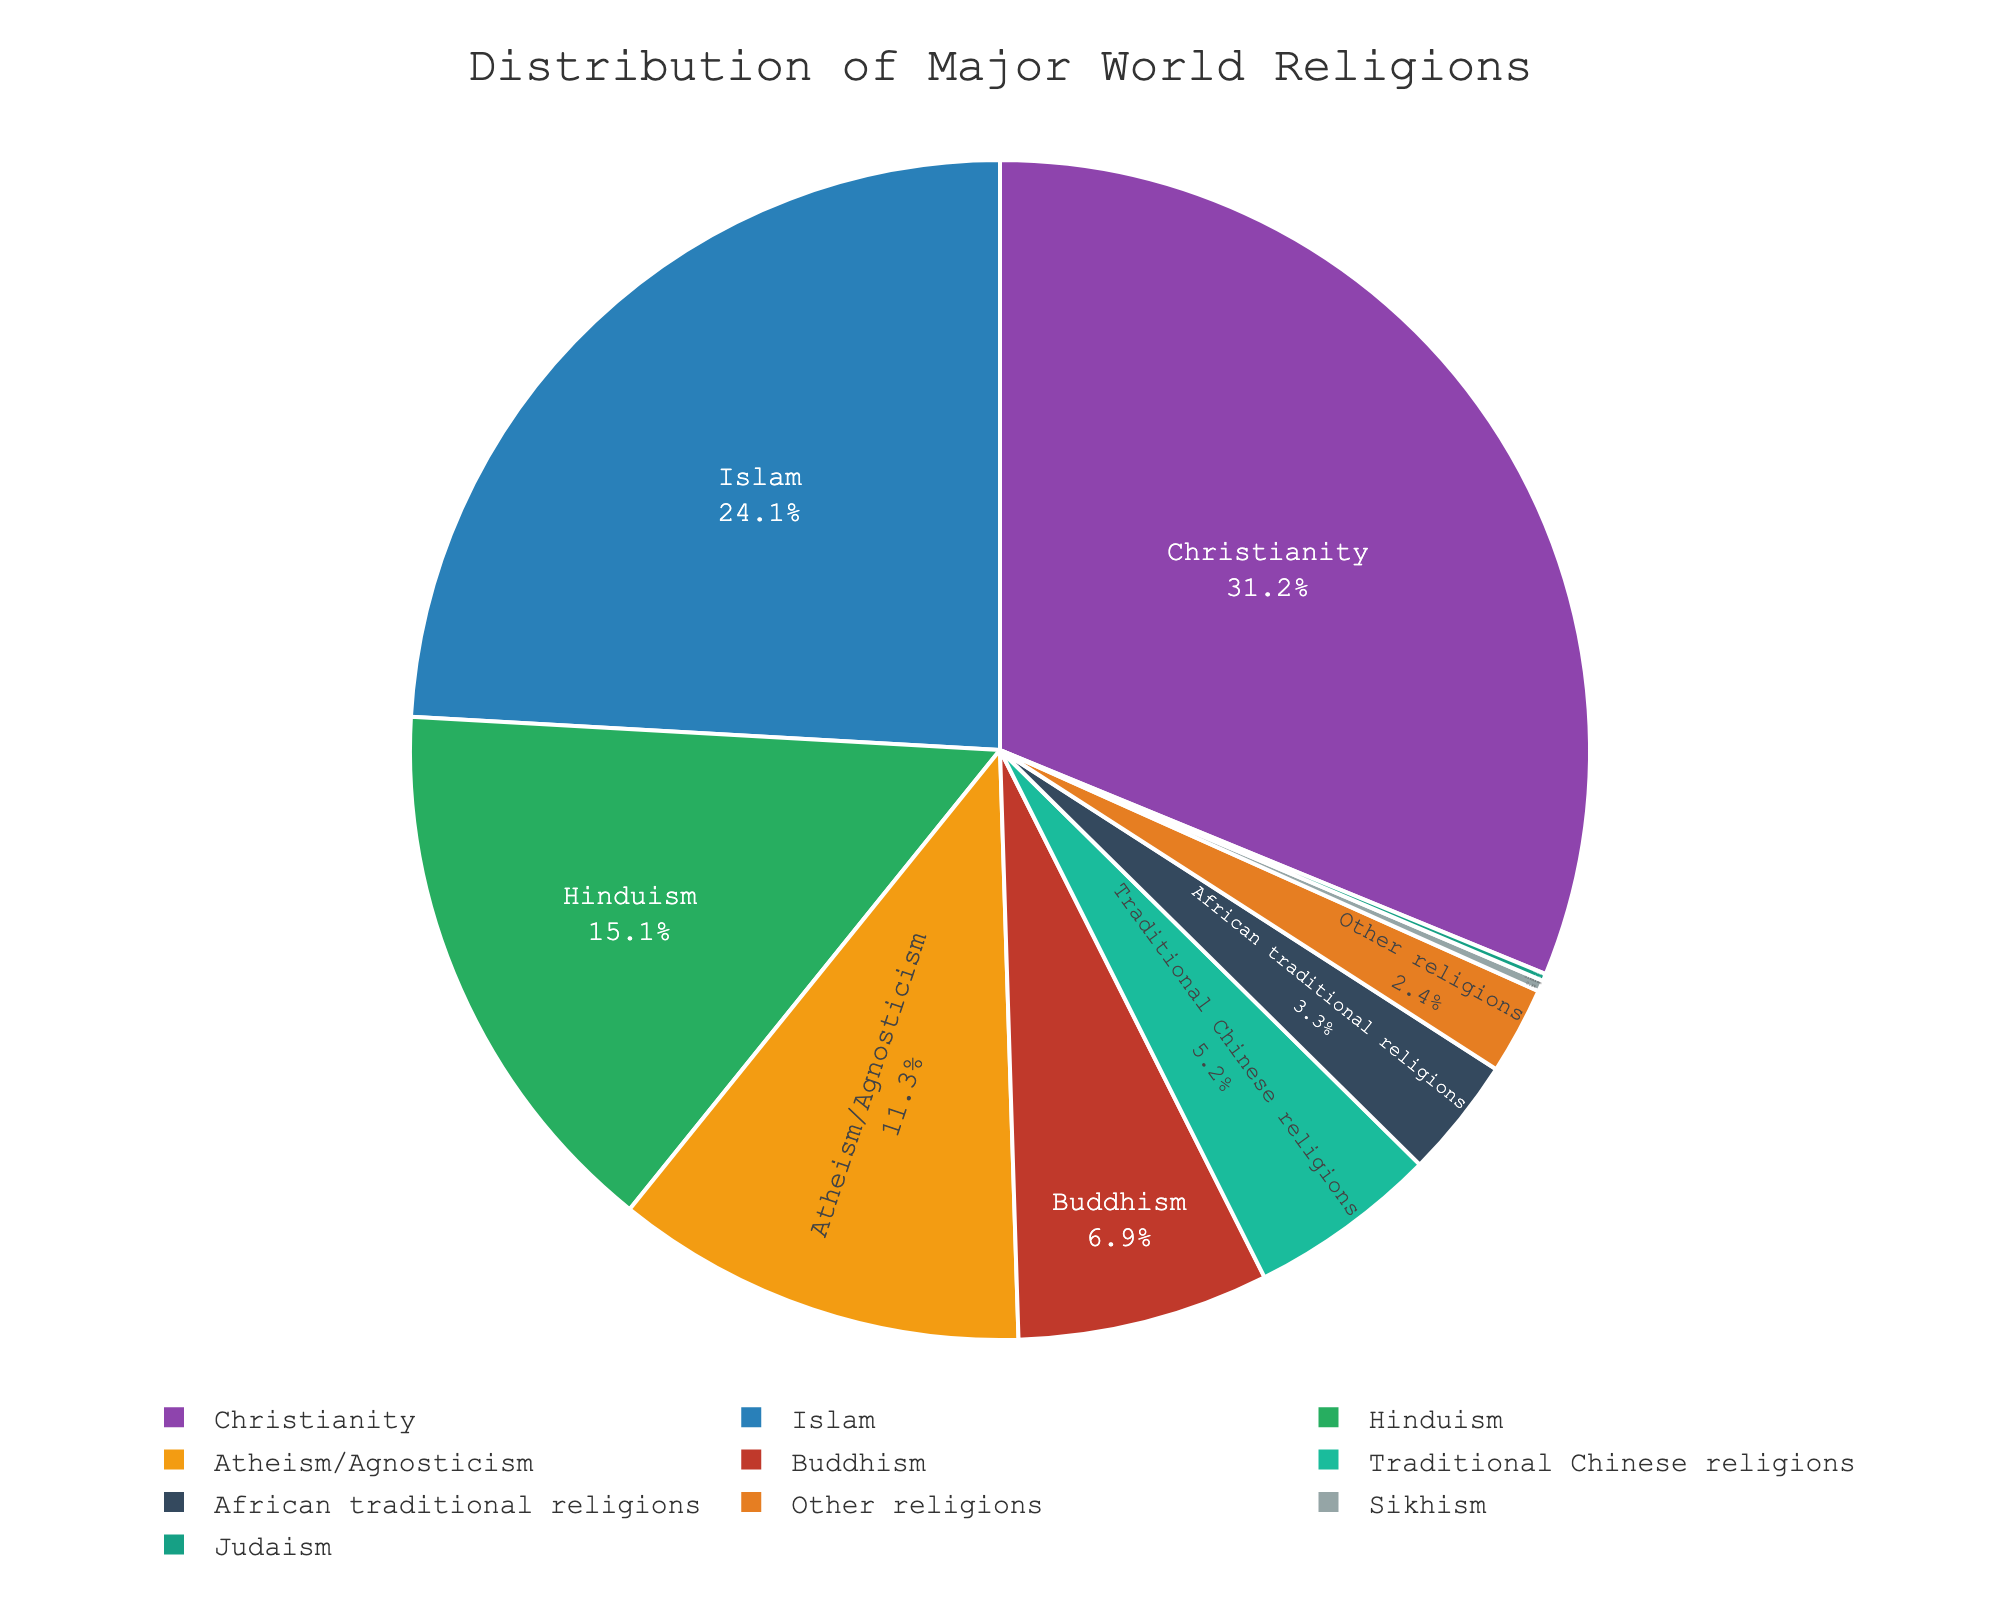What percentage of the global population adheres to Christianity? First, refer to the slice of the pie chart labeled "Christianity." The percentage is usually displayed either inside or near the slice.
Answer: 31.2% Which religion holds the second-largest percentage of the world's population? Identify the top two slices of the pie chart by their size. The largest slice is for Christianity, and the next largest is Islam.
Answer: Islam What is the combined percentage of Hinduism and Buddhism? Locate the slices labeled "Hinduism" and "Buddhism" on the pie chart. Add their percentages: 15.1% (Hinduism) + 6.9% (Buddhism).
Answer: 22.0% Are there more people practicing Traditional Chinese religions or African traditional religions? Compare the sizes of the two specific slices: Traditional Chinese religions (5.2%) and African traditional religions (3.3%).
Answer: Traditional Chinese religions What is the visual representation color for the sector representing Atheism/Agnosticism? Locate the slice of the pie chart labeled "Atheism/Agnosticism" and identify the color used to represent it.
Answer: Grey (or a related shade) How much larger is the Christian population compared to the Buddhist population? Subtract the percentage of Buddhists from the percentage of Christians: 31.2% (Christianity) - 6.9% (Buddhism).
Answer: 24.3% Which categories have percentages less than 1%? Look at the pie chart for slices representing percentages smaller than 1%. Identify and list them.
Answer: Sikhism, Judaism If you combine the groups "Other religions" and "Atheism/Agnosticism", what percentage of the global population do they account for? Add the percentages for "Other religions" and "Atheism/Agnosticism": 2.4% + 11.3%.
Answer: 13.7% What fraction of the pie chart represents religions other than Christianity, Islam, and Hinduism? Sum the percentages of all slices except Christianity, Islam, and Hinduism: 6.9% + 0.3% + 0.2% + 5.2% + 3.3% + 11.3% + 2.4%.
Answer: 29.6% What is the alphabetical order of religions represented in the pie chart? List the names of all religions in the chart in alphabetical order: "African traditional religions," "Atheism/Agnosticism," "Buddhism," "Christianity," "Hinduism," "Islam," "Judaism," "Other religions," "Sikhism," "Traditional Chinese religions."
Answer: African traditional religions, Atheism/Agnosticism, Buddhism, Christianity, Hinduism, Islam, Judaism, Other religions, Sikhism, Traditional Chinese religions 